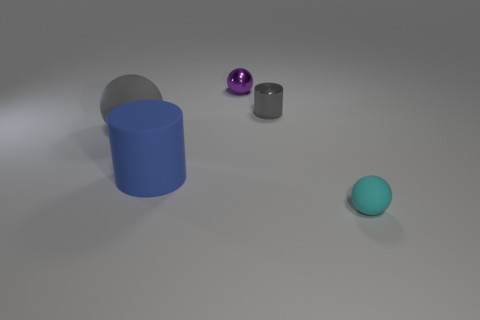Subtract all tiny balls. How many balls are left? 1 Subtract 3 balls. How many balls are left? 0 Subtract all blue cylinders. How many cylinders are left? 1 Add 4 large yellow blocks. How many objects exist? 9 Subtract all balls. How many objects are left? 2 Add 5 gray metallic things. How many gray metallic things exist? 6 Subtract 1 gray spheres. How many objects are left? 4 Subtract all purple balls. Subtract all red blocks. How many balls are left? 2 Subtract all small matte objects. Subtract all cyan spheres. How many objects are left? 3 Add 1 tiny matte balls. How many tiny matte balls are left? 2 